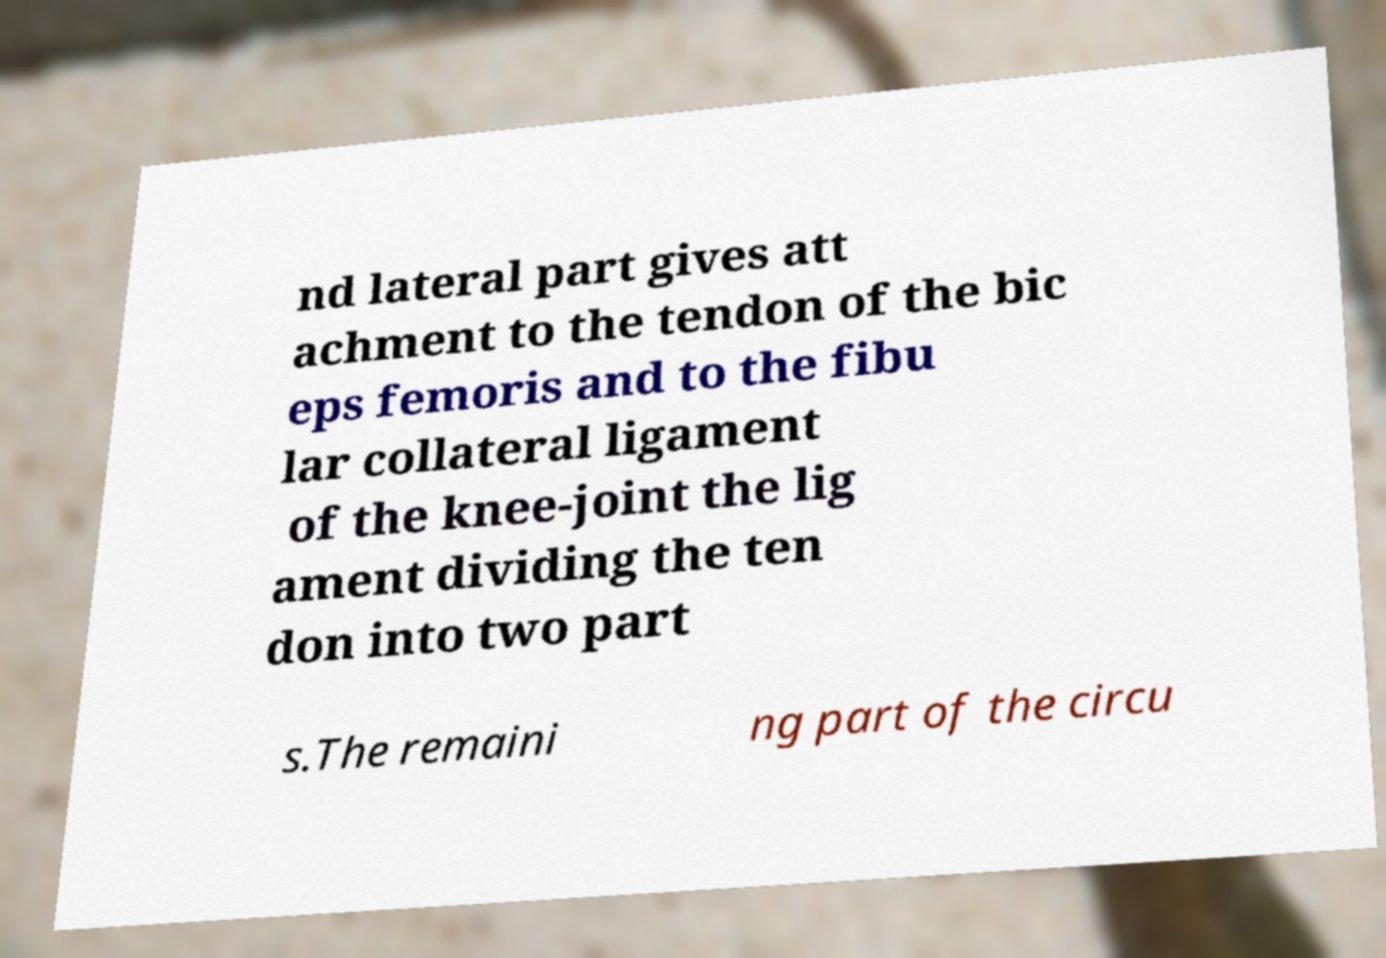Can you read and provide the text displayed in the image?This photo seems to have some interesting text. Can you extract and type it out for me? nd lateral part gives att achment to the tendon of the bic eps femoris and to the fibu lar collateral ligament of the knee-joint the lig ament dividing the ten don into two part s.The remaini ng part of the circu 